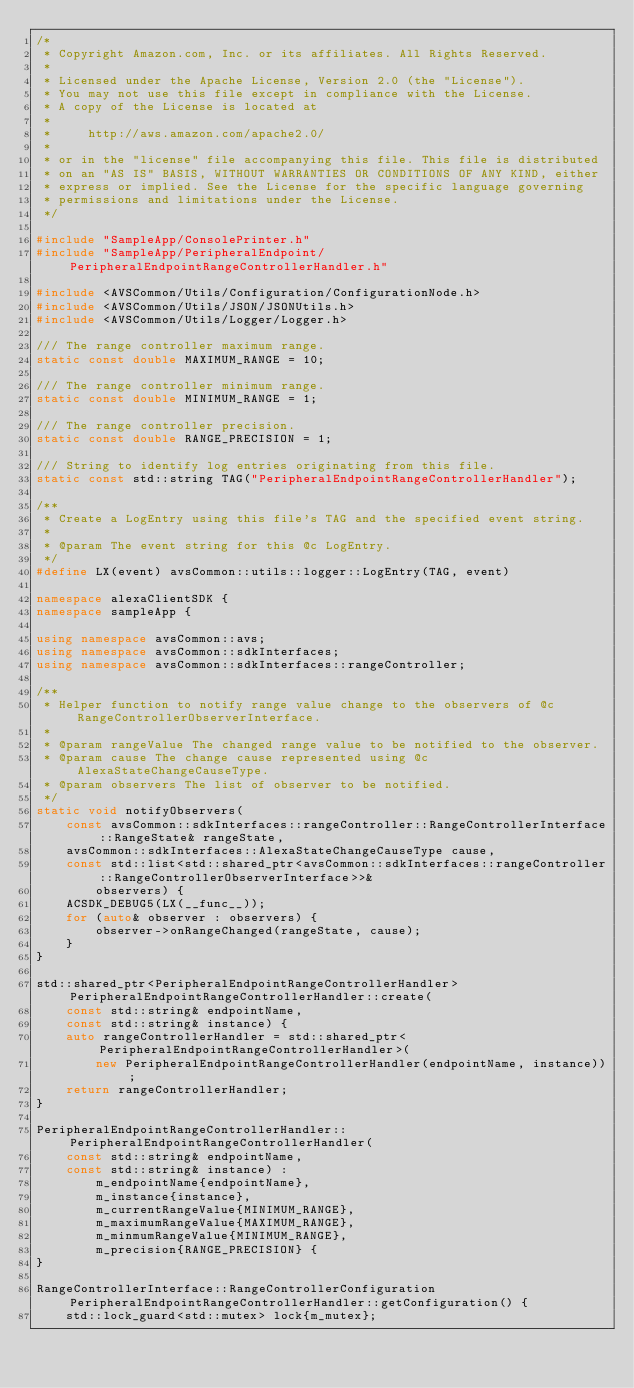<code> <loc_0><loc_0><loc_500><loc_500><_C++_>/*
 * Copyright Amazon.com, Inc. or its affiliates. All Rights Reserved.
 *
 * Licensed under the Apache License, Version 2.0 (the "License").
 * You may not use this file except in compliance with the License.
 * A copy of the License is located at
 *
 *     http://aws.amazon.com/apache2.0/
 *
 * or in the "license" file accompanying this file. This file is distributed
 * on an "AS IS" BASIS, WITHOUT WARRANTIES OR CONDITIONS OF ANY KIND, either
 * express or implied. See the License for the specific language governing
 * permissions and limitations under the License.
 */

#include "SampleApp/ConsolePrinter.h"
#include "SampleApp/PeripheralEndpoint/PeripheralEndpointRangeControllerHandler.h"

#include <AVSCommon/Utils/Configuration/ConfigurationNode.h>
#include <AVSCommon/Utils/JSON/JSONUtils.h>
#include <AVSCommon/Utils/Logger/Logger.h>

/// The range controller maximum range.
static const double MAXIMUM_RANGE = 10;

/// The range controller minimum range.
static const double MINIMUM_RANGE = 1;

/// The range controller precision.
static const double RANGE_PRECISION = 1;

/// String to identify log entries originating from this file.
static const std::string TAG("PeripheralEndpointRangeControllerHandler");

/**
 * Create a LogEntry using this file's TAG and the specified event string.
 *
 * @param The event string for this @c LogEntry.
 */
#define LX(event) avsCommon::utils::logger::LogEntry(TAG, event)

namespace alexaClientSDK {
namespace sampleApp {

using namespace avsCommon::avs;
using namespace avsCommon::sdkInterfaces;
using namespace avsCommon::sdkInterfaces::rangeController;

/**
 * Helper function to notify range value change to the observers of @c RangeControllerObserverInterface.
 *
 * @param rangeValue The changed range value to be notified to the observer.
 * @param cause The change cause represented using @c AlexaStateChangeCauseType.
 * @param observers The list of observer to be notified.
 */
static void notifyObservers(
    const avsCommon::sdkInterfaces::rangeController::RangeControllerInterface::RangeState& rangeState,
    avsCommon::sdkInterfaces::AlexaStateChangeCauseType cause,
    const std::list<std::shared_ptr<avsCommon::sdkInterfaces::rangeController::RangeControllerObserverInterface>>&
        observers) {
    ACSDK_DEBUG5(LX(__func__));
    for (auto& observer : observers) {
        observer->onRangeChanged(rangeState, cause);
    }
}

std::shared_ptr<PeripheralEndpointRangeControllerHandler> PeripheralEndpointRangeControllerHandler::create(
    const std::string& endpointName,
    const std::string& instance) {
    auto rangeControllerHandler = std::shared_ptr<PeripheralEndpointRangeControllerHandler>(
        new PeripheralEndpointRangeControllerHandler(endpointName, instance));
    return rangeControllerHandler;
}

PeripheralEndpointRangeControllerHandler::PeripheralEndpointRangeControllerHandler(
    const std::string& endpointName,
    const std::string& instance) :
        m_endpointName{endpointName},
        m_instance{instance},
        m_currentRangeValue{MINIMUM_RANGE},
        m_maximumRangeValue{MAXIMUM_RANGE},
        m_minmumRangeValue{MINIMUM_RANGE},
        m_precision{RANGE_PRECISION} {
}

RangeControllerInterface::RangeControllerConfiguration PeripheralEndpointRangeControllerHandler::getConfiguration() {
    std::lock_guard<std::mutex> lock{m_mutex};</code> 